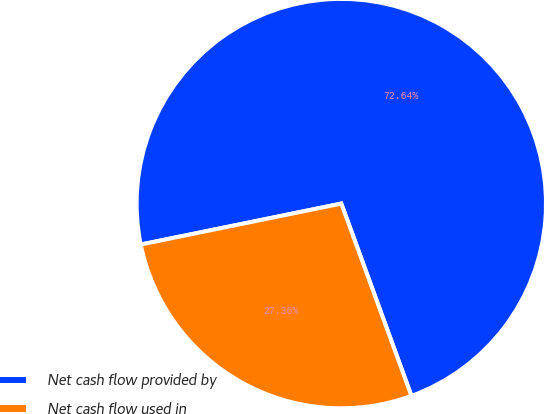<chart> <loc_0><loc_0><loc_500><loc_500><pie_chart><fcel>Net cash flow provided by<fcel>Net cash flow used in<nl><fcel>72.64%<fcel>27.36%<nl></chart> 